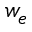Convert formula to latex. <formula><loc_0><loc_0><loc_500><loc_500>w _ { e }</formula> 